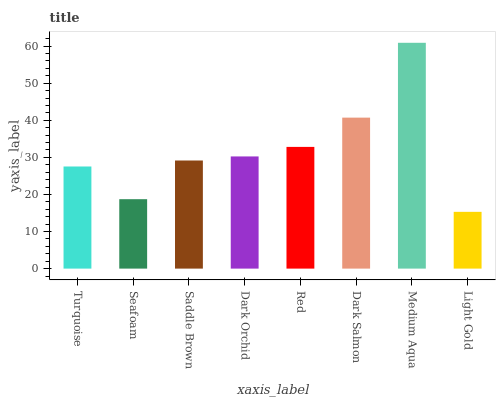Is Light Gold the minimum?
Answer yes or no. Yes. Is Medium Aqua the maximum?
Answer yes or no. Yes. Is Seafoam the minimum?
Answer yes or no. No. Is Seafoam the maximum?
Answer yes or no. No. Is Turquoise greater than Seafoam?
Answer yes or no. Yes. Is Seafoam less than Turquoise?
Answer yes or no. Yes. Is Seafoam greater than Turquoise?
Answer yes or no. No. Is Turquoise less than Seafoam?
Answer yes or no. No. Is Dark Orchid the high median?
Answer yes or no. Yes. Is Saddle Brown the low median?
Answer yes or no. Yes. Is Seafoam the high median?
Answer yes or no. No. Is Red the low median?
Answer yes or no. No. 